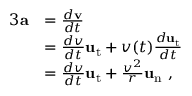Convert formula to latex. <formula><loc_0><loc_0><loc_500><loc_500>{ \begin{array} { r l } { { 3 } a } & { = { \frac { d v } { d t } } } \\ & { = { \frac { d v } { d t } } u _ { t } + v ( t ) { \frac { d u _ { t } } { d t } } } \\ & { = { \frac { d v } { d t } } u _ { t } + { \frac { v ^ { 2 } } { r } } u _ { n } \ , } \end{array} }</formula> 